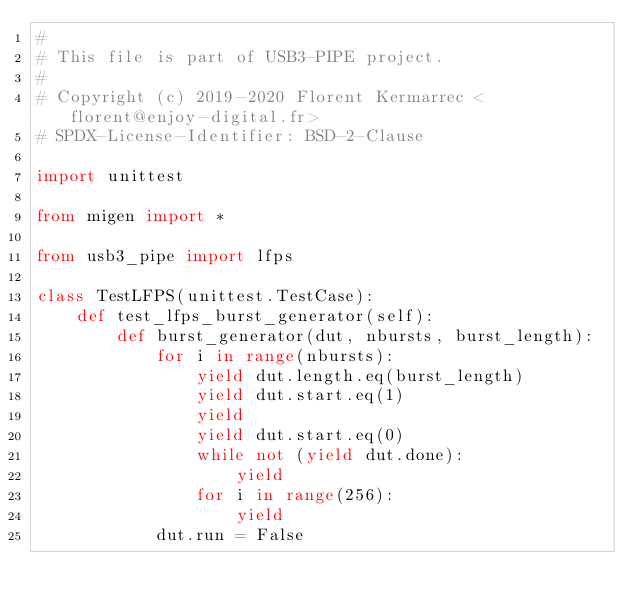Convert code to text. <code><loc_0><loc_0><loc_500><loc_500><_Python_>#
# This file is part of USB3-PIPE project.
#
# Copyright (c) 2019-2020 Florent Kermarrec <florent@enjoy-digital.fr>
# SPDX-License-Identifier: BSD-2-Clause

import unittest

from migen import *

from usb3_pipe import lfps

class TestLFPS(unittest.TestCase):
    def test_lfps_burst_generator(self):
        def burst_generator(dut, nbursts, burst_length):
            for i in range(nbursts):
                yield dut.length.eq(burst_length)
                yield dut.start.eq(1)
                yield
                yield dut.start.eq(0)
                while not (yield dut.done):
                    yield
                for i in range(256):
                    yield
            dut.run = False
</code> 